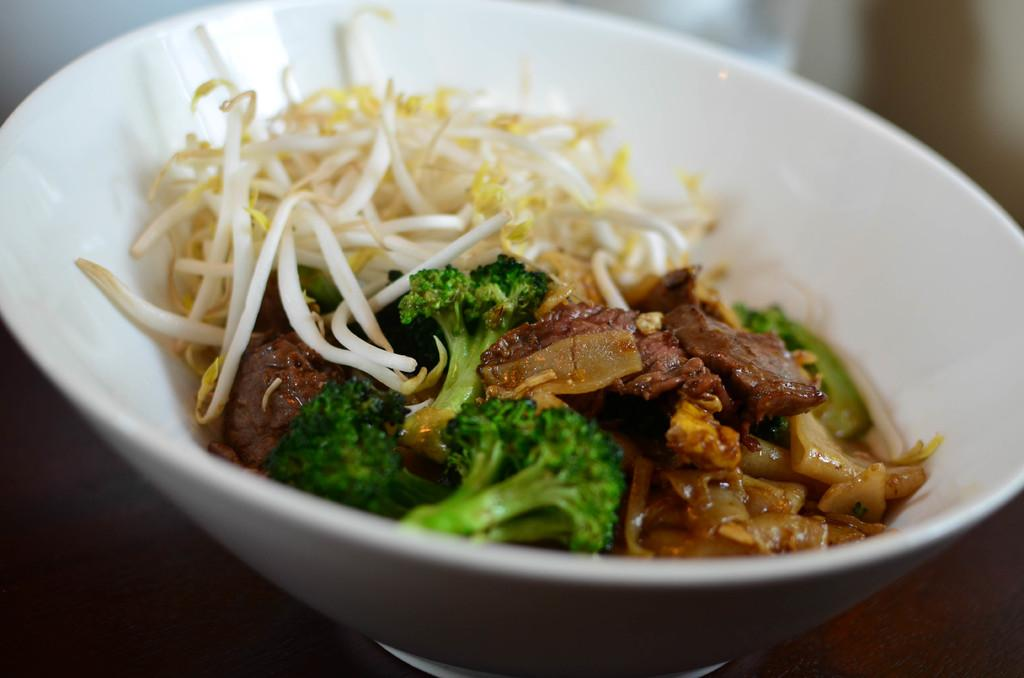What types of food are in the bowl in the image? There is meat, cabbage, and onion pieces in the bowl. Are there any other ingredients in the bowl? Yes, there are other objects in the bowl. Where is the bowl located in the image? The bowl is kept on a table. What type of street development can be seen in the image? There is no street development visible in the image; it features a bowl of food on a table. How many buns are present in the image? There is no mention of buns in the image; it only shows a bowl of food with meat, cabbage, onion pieces, and other objects. 